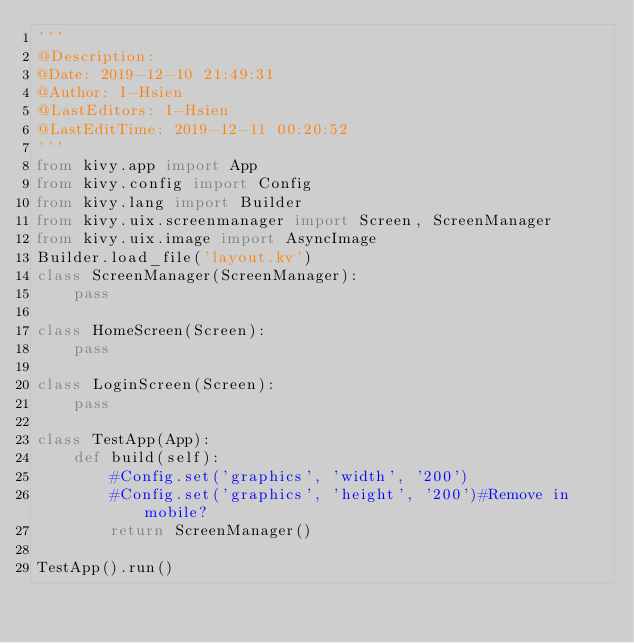Convert code to text. <code><loc_0><loc_0><loc_500><loc_500><_Python_>'''
@Description:
@Date: 2019-12-10 21:49:31
@Author: I-Hsien
@LastEditors: I-Hsien
@LastEditTime: 2019-12-11 00:20:52
'''
from kivy.app import App
from kivy.config import Config
from kivy.lang import Builder
from kivy.uix.screenmanager import Screen, ScreenManager
from kivy.uix.image import AsyncImage
Builder.load_file('layout.kv')
class ScreenManager(ScreenManager):
    pass

class HomeScreen(Screen):
    pass

class LoginScreen(Screen):
    pass

class TestApp(App):
    def build(self):
        #Config.set('graphics', 'width', '200')
        #Config.set('graphics', 'height', '200')#Remove in mobile?
        return ScreenManager()

TestApp().run()
</code> 